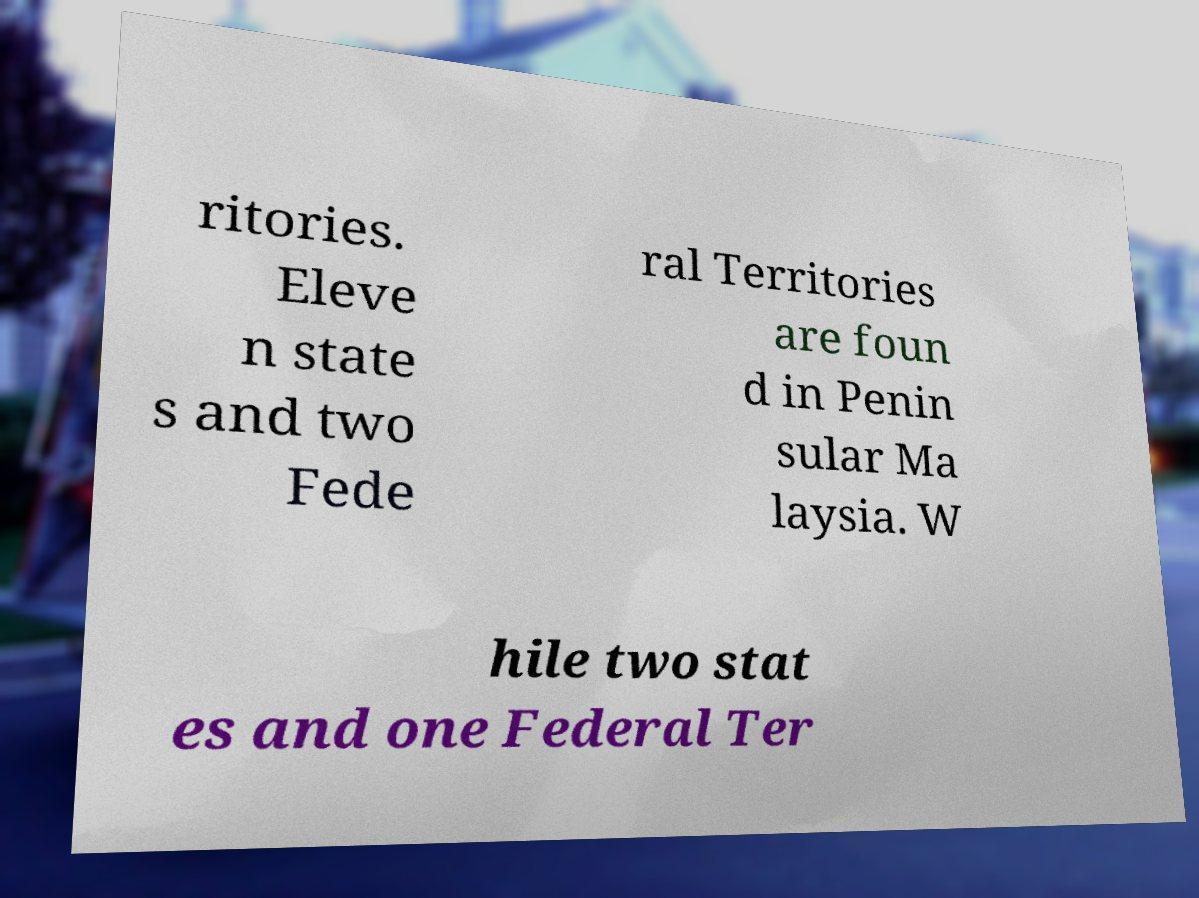There's text embedded in this image that I need extracted. Can you transcribe it verbatim? ritories. Eleve n state s and two Fede ral Territories are foun d in Penin sular Ma laysia. W hile two stat es and one Federal Ter 